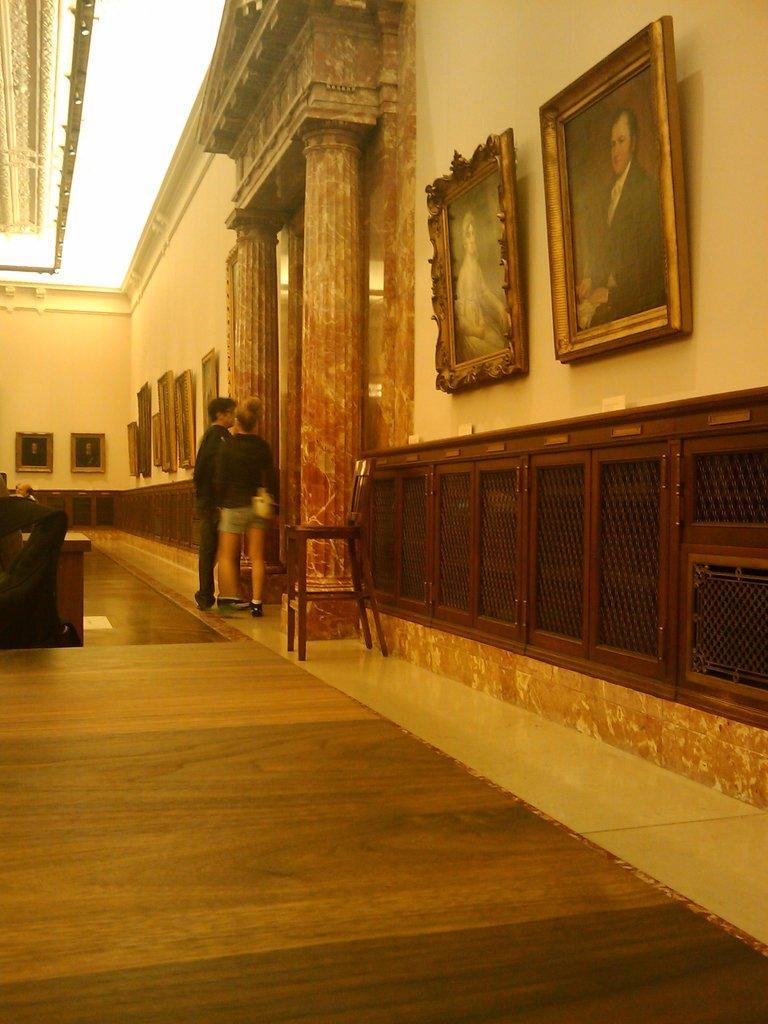How would you summarize this image in a sentence or two? In this image there are two persons standing on the floor. On the right side there is a wall on which there are photo frames. At the top there are lights. On the left side there is a person standing beside the desk. There are so many photo frames attached to the wall. There is a stool in the middle, Beside the stool there are pillars. 